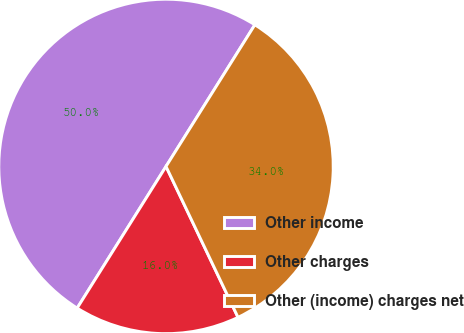Convert chart to OTSL. <chart><loc_0><loc_0><loc_500><loc_500><pie_chart><fcel>Other income<fcel>Other charges<fcel>Other (income) charges net<nl><fcel>50.0%<fcel>16.0%<fcel>34.0%<nl></chart> 